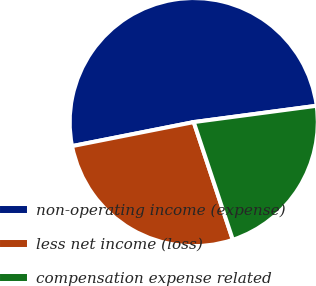<chart> <loc_0><loc_0><loc_500><loc_500><pie_chart><fcel>non-operating income (expense)<fcel>less net income (loss)<fcel>compensation expense related<nl><fcel>51.0%<fcel>27.0%<fcel>22.0%<nl></chart> 